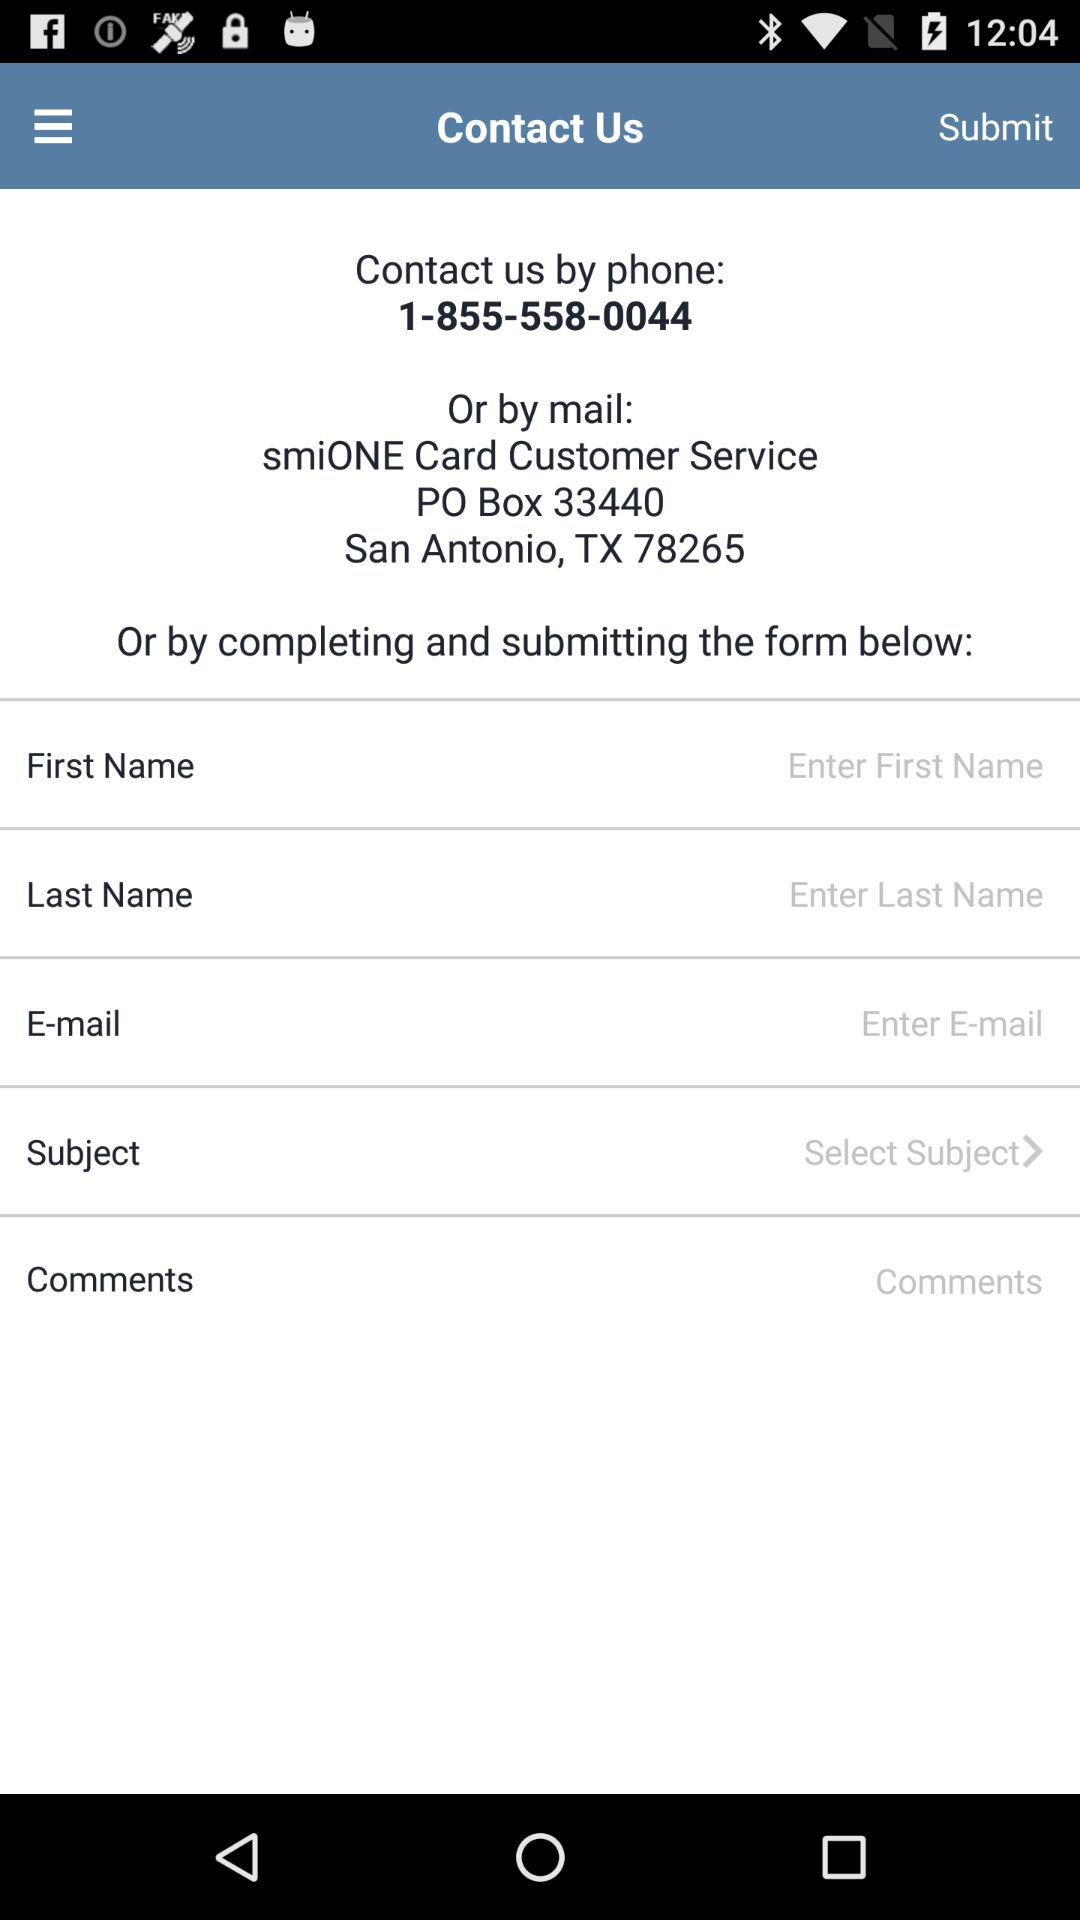What is the contact number? The contact number is 1-855-558-0044. 